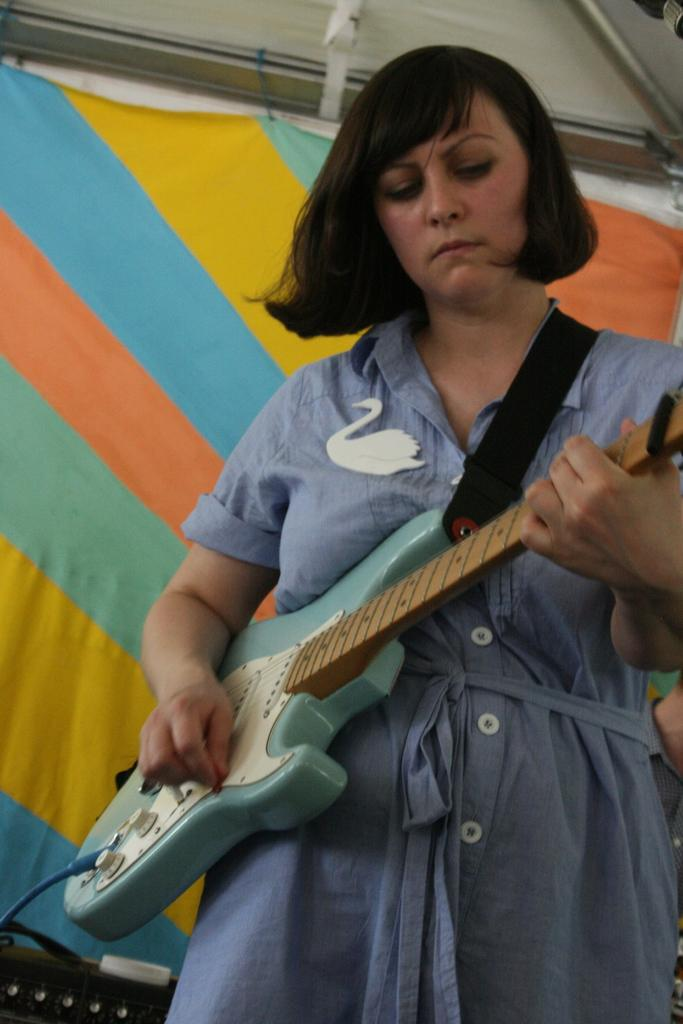Who is the main subject in the image? There is a lady in the image. What is the lady wearing? The lady is wearing a blue dress. What is the lady holding in the image? The lady is holding a guitar. What can be seen in the background of the image? There is a sheet covered in the background of the image. What type of plastic is visible in the image? There is no plastic visible in the image. Is there any poison present in the image? There is no mention of poison in the image. 